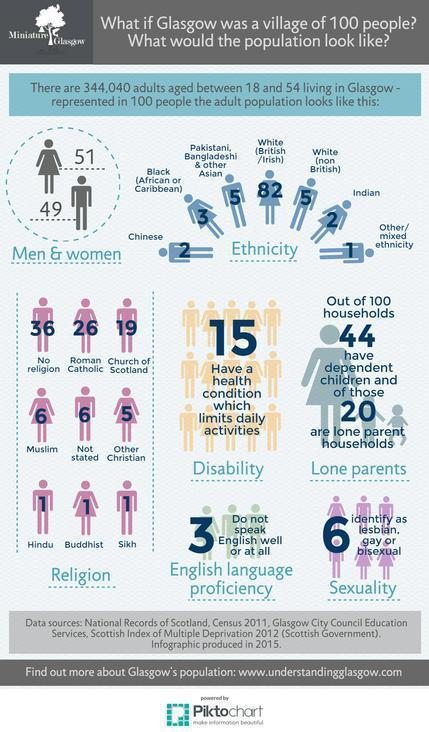How many adults aged 18-54 years living in Glasgow are men if it is represented as a village of 100 people?
Answer the question with a short phrase. 49 How many adults aged 18-54 years living in Glasgow are Indian if it is represented as a village of 100 people? 2 How many adults aged 18-54 years living in Glasgow are Whites (British/Irish) if it is represented as a village of 100 people? 82 How many adult women aged 18-54 years living in Glasgow are Roman Catholic if it is represented as a village of 100 people? 26 How many adult women aged 18-54 years living in Glasgow are Hindus if it is represented as a village of 100 people? 1 How many adults aged 18-54 years living in Glasgow are identified as lesbian, gay or bisexual if it is represented as a village of 100 people? 6 How many adults aged 18-54 years living in Glasgow are women if it is represented as a village of 100 people? 51 